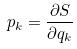<formula> <loc_0><loc_0><loc_500><loc_500>p _ { k } = \frac { \partial S } { \partial q _ { k } }</formula> 